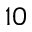<formula> <loc_0><loc_0><loc_500><loc_500>1 0</formula> 